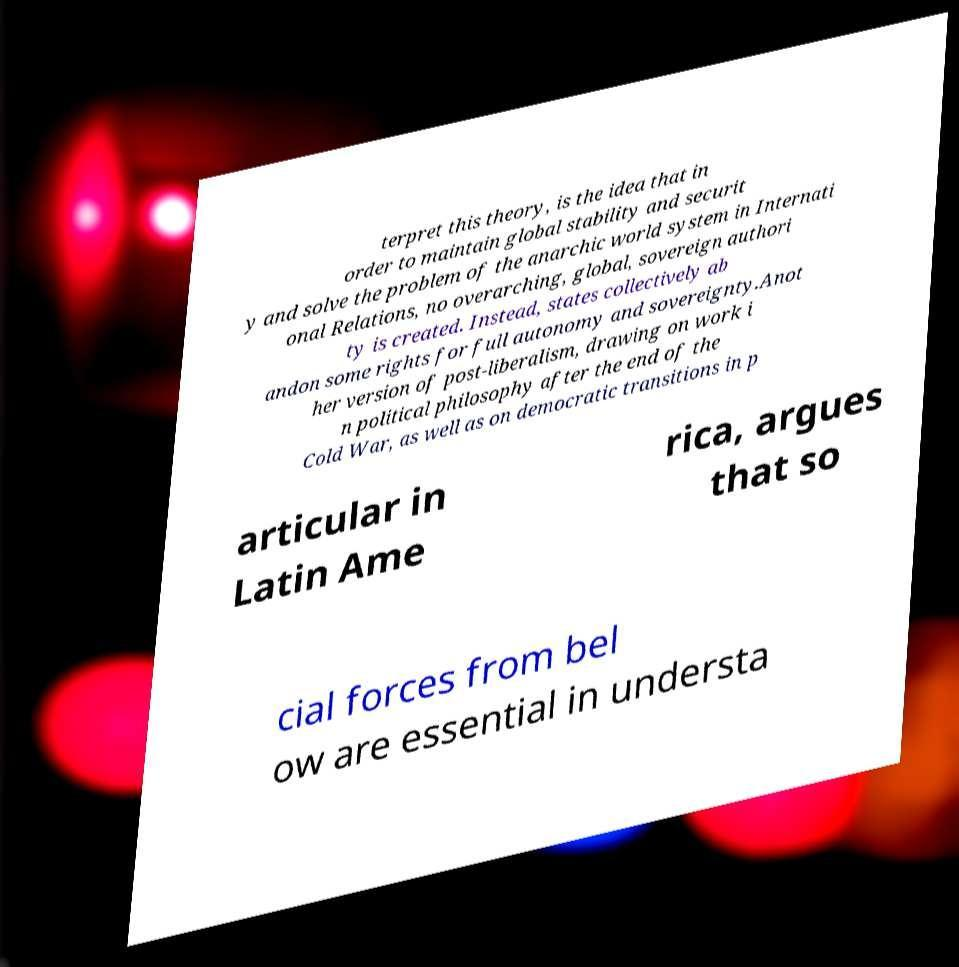Can you read and provide the text displayed in the image?This photo seems to have some interesting text. Can you extract and type it out for me? terpret this theory, is the idea that in order to maintain global stability and securit y and solve the problem of the anarchic world system in Internati onal Relations, no overarching, global, sovereign authori ty is created. Instead, states collectively ab andon some rights for full autonomy and sovereignty.Anot her version of post-liberalism, drawing on work i n political philosophy after the end of the Cold War, as well as on democratic transitions in p articular in Latin Ame rica, argues that so cial forces from bel ow are essential in understa 